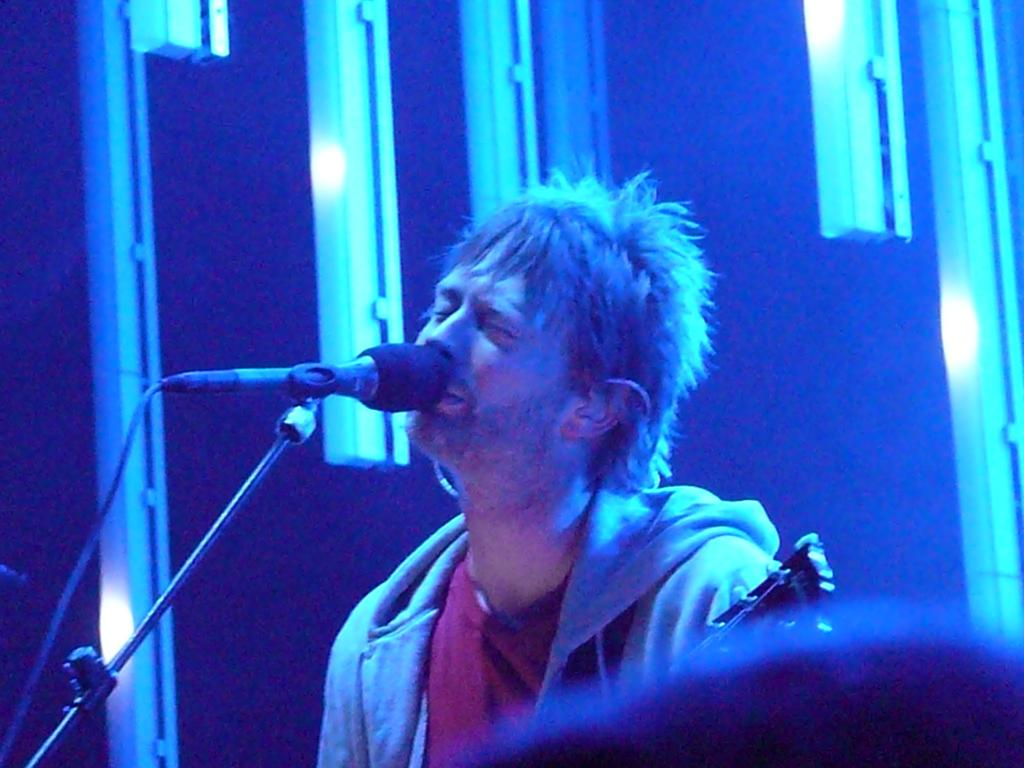Who is the main subject in the image? There is a man in the center of the image. What object is associated with the man in the image? There is a guitar in the image. What equipment is present for amplifying sound? There is a microphone with a stand in the image. What can be seen in the background of the image? There is a wall and lights visible in the background of the image. What type of map can be seen on the dock in the image? There is no map or dock present in the image. How does the expansion of the room affect the lighting in the image? The image does not show any expansion of the room, and therefore it cannot be determined how it would affect the lighting. 